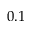<formula> <loc_0><loc_0><loc_500><loc_500>0 . 1</formula> 